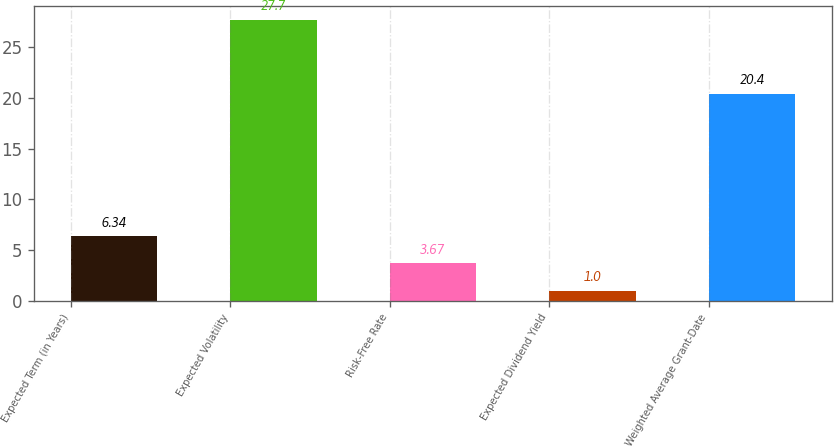Convert chart. <chart><loc_0><loc_0><loc_500><loc_500><bar_chart><fcel>Expected Term (in Years)<fcel>Expected Volatility<fcel>Risk-Free Rate<fcel>Expected Dividend Yield<fcel>Weighted Average Grant-Date<nl><fcel>6.34<fcel>27.7<fcel>3.67<fcel>1<fcel>20.4<nl></chart> 